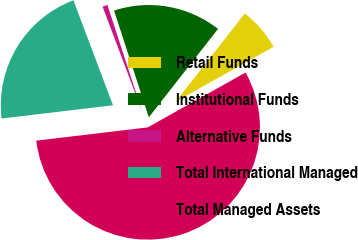Convert chart to OTSL. <chart><loc_0><loc_0><loc_500><loc_500><pie_chart><fcel>Retail Funds<fcel>Institutional Funds<fcel>Alternative Funds<fcel>Total International Managed<fcel>Total Managed Assets<nl><fcel>6.29%<fcel>15.59%<fcel>0.73%<fcel>21.14%<fcel>56.26%<nl></chart> 